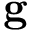Convert formula to latex. <formula><loc_0><loc_0><loc_500><loc_500>g</formula> 